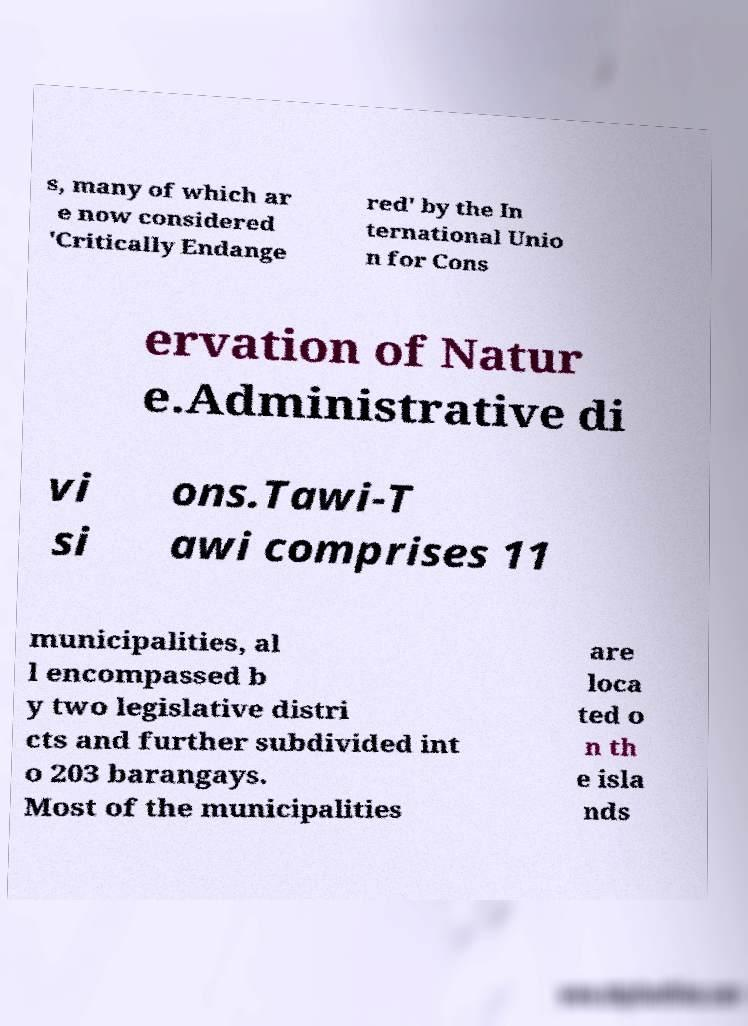Please read and relay the text visible in this image. What does it say? s, many of which ar e now considered 'Critically Endange red' by the In ternational Unio n for Cons ervation of Natur e.Administrative di vi si ons.Tawi-T awi comprises 11 municipalities, al l encompassed b y two legislative distri cts and further subdivided int o 203 barangays. Most of the municipalities are loca ted o n th e isla nds 